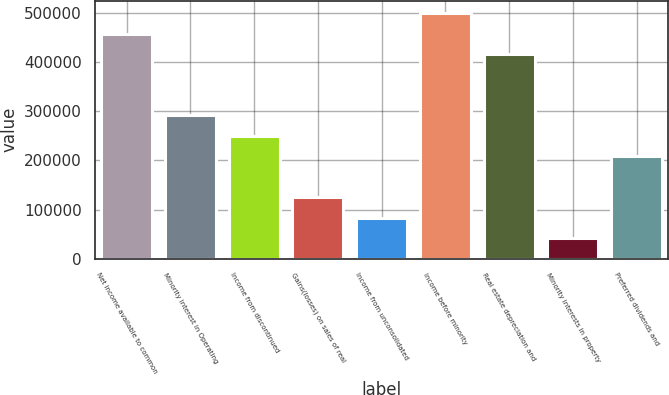Convert chart. <chart><loc_0><loc_0><loc_500><loc_500><bar_chart><fcel>Net income available to common<fcel>Minority interest in Operating<fcel>Income from discontinued<fcel>Gains(losses) on sales of real<fcel>Income from unconsolidated<fcel>Income before minority<fcel>Real estate depreciation and<fcel>Minority interests in property<fcel>Preferred dividends and<nl><fcel>457484<fcel>291156<fcel>249574<fcel>124827<fcel>83245.4<fcel>499066<fcel>415902<fcel>41663.3<fcel>207992<nl></chart> 